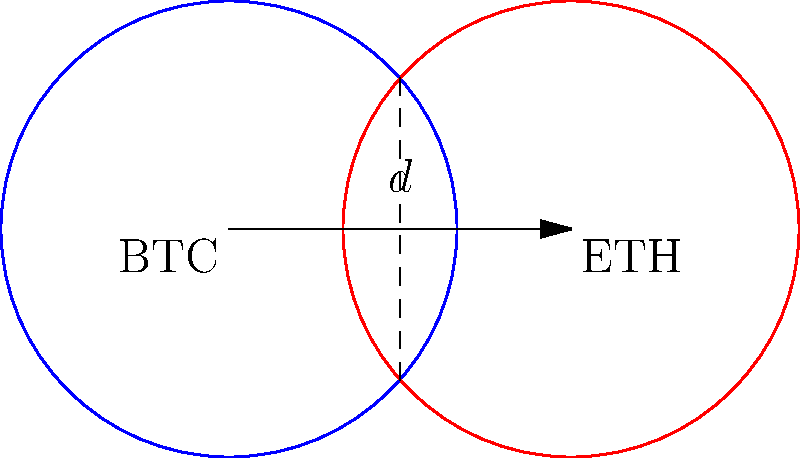In the decentralized future of finance, two major cryptocurrencies, Bitcoin (BTC) and Ethereum (ETH), are represented by overlapping circles. Each circle has a radius of 1 unit, and their centers are separated by a distance $d = 1.5$ units. Calculate the area of the overlapping region, which represents the market share where these two cryptocurrencies compete directly. Express your answer in terms of $\pi$. To solve this problem, we'll use the formula for the area of intersection between two circles. Let's approach this step-by-step:

1) First, we need to find the angle $\theta$ at the center of each circle that is subtended by the overlapping region:

   $\cos(\frac{\theta}{2}) = \frac{d}{2r} = \frac{1.5}{2(1)} = 0.75$

2) Therefore, $\theta = 2 \arccos(0.75) \approx 1.5708$ radians

3) The area of the overlapping region is given by:

   $A = 2r^2 (\frac{\theta}{2} - \sin(\frac{\theta}{2})\cos(\frac{\theta}{2}))$

4) Substituting our values:

   $A = 2(1^2) (\frac{1.5708}{2} - \sin(\frac{1.5708}{2})\cos(\frac{1.5708}{2}))$

5) Simplify:

   $A = 2 (0.7854 - \sin(0.7854)\cos(0.7854))$
   $A = 2 (0.7854 - 0.5590)$
   $A = 2 (0.2264)$
   $A = 0.4528$

6) This area is in square units. To express it in terms of $\pi$, we divide by $\pi$:

   $\frac{A}{\pi} = \frac{0.4528}{\pi} \approx 0.1442$

7) This is very close to $\frac{1}{7}$, which is a simpler expression.

Therefore, the area of overlap is approximately $\frac{\pi}{7}$ square units.
Answer: $\frac{\pi}{7}$ square units 